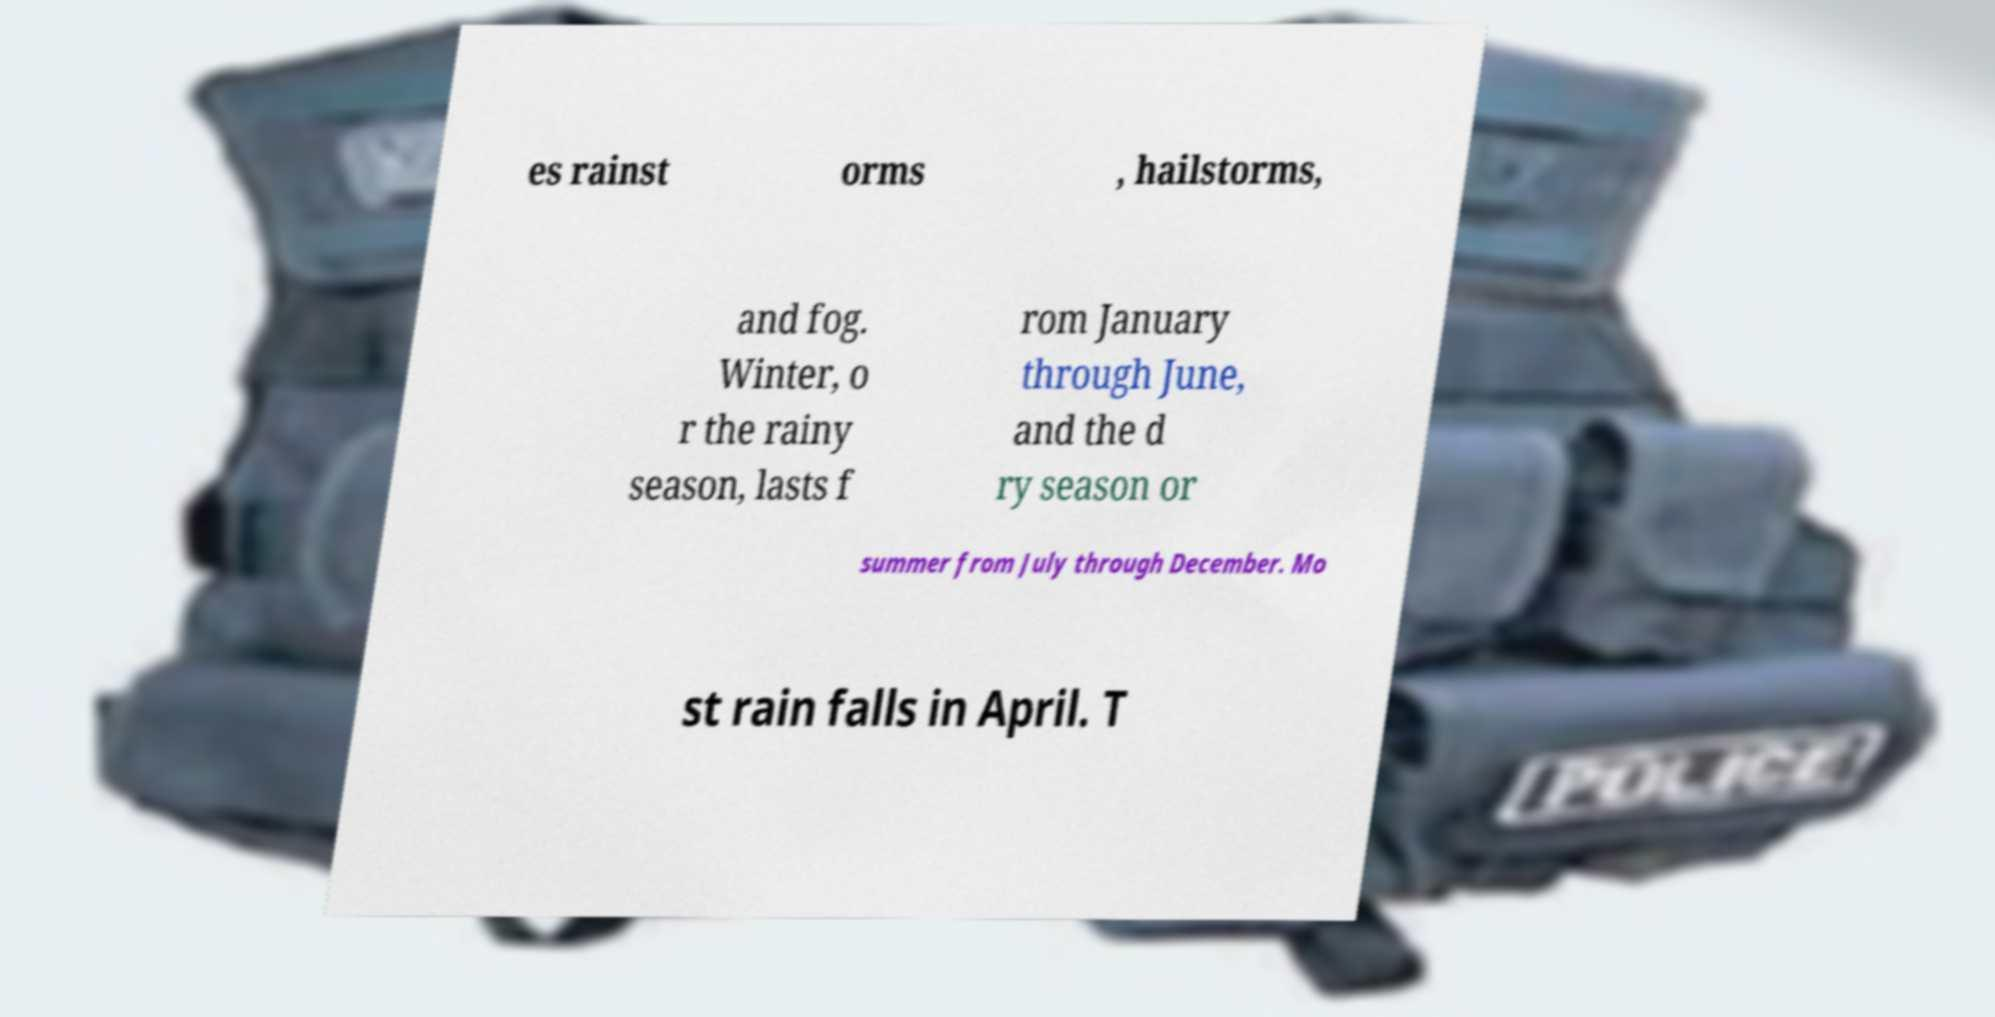There's text embedded in this image that I need extracted. Can you transcribe it verbatim? es rainst orms , hailstorms, and fog. Winter, o r the rainy season, lasts f rom January through June, and the d ry season or summer from July through December. Mo st rain falls in April. T 